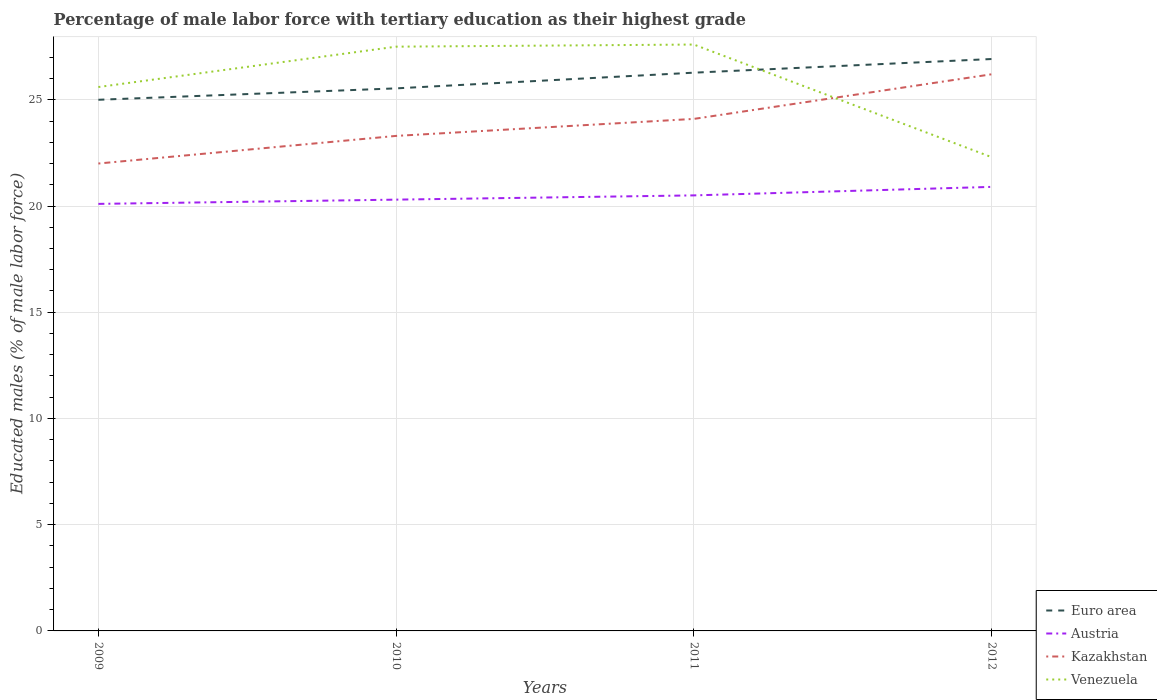How many different coloured lines are there?
Ensure brevity in your answer.  4. In which year was the percentage of male labor force with tertiary education in Euro area maximum?
Ensure brevity in your answer.  2009. What is the total percentage of male labor force with tertiary education in Venezuela in the graph?
Give a very brief answer. 5.2. What is the difference between the highest and the second highest percentage of male labor force with tertiary education in Venezuela?
Keep it short and to the point. 5.3. What is the difference between the highest and the lowest percentage of male labor force with tertiary education in Venezuela?
Provide a succinct answer. 2. Is the percentage of male labor force with tertiary education in Kazakhstan strictly greater than the percentage of male labor force with tertiary education in Venezuela over the years?
Provide a succinct answer. No. What is the difference between two consecutive major ticks on the Y-axis?
Your answer should be compact. 5. Are the values on the major ticks of Y-axis written in scientific E-notation?
Provide a succinct answer. No. Does the graph contain any zero values?
Your answer should be compact. No. What is the title of the graph?
Keep it short and to the point. Percentage of male labor force with tertiary education as their highest grade. What is the label or title of the X-axis?
Your answer should be compact. Years. What is the label or title of the Y-axis?
Your answer should be very brief. Educated males (% of male labor force). What is the Educated males (% of male labor force) of Euro area in 2009?
Your answer should be very brief. 25. What is the Educated males (% of male labor force) in Austria in 2009?
Your answer should be very brief. 20.1. What is the Educated males (% of male labor force) of Kazakhstan in 2009?
Your answer should be compact. 22. What is the Educated males (% of male labor force) of Venezuela in 2009?
Offer a terse response. 25.6. What is the Educated males (% of male labor force) of Euro area in 2010?
Make the answer very short. 25.54. What is the Educated males (% of male labor force) in Austria in 2010?
Offer a very short reply. 20.3. What is the Educated males (% of male labor force) in Kazakhstan in 2010?
Provide a succinct answer. 23.3. What is the Educated males (% of male labor force) of Euro area in 2011?
Your answer should be compact. 26.28. What is the Educated males (% of male labor force) of Kazakhstan in 2011?
Make the answer very short. 24.1. What is the Educated males (% of male labor force) in Venezuela in 2011?
Your answer should be very brief. 27.6. What is the Educated males (% of male labor force) in Euro area in 2012?
Make the answer very short. 26.92. What is the Educated males (% of male labor force) of Austria in 2012?
Provide a short and direct response. 20.9. What is the Educated males (% of male labor force) of Kazakhstan in 2012?
Give a very brief answer. 26.2. What is the Educated males (% of male labor force) in Venezuela in 2012?
Your response must be concise. 22.3. Across all years, what is the maximum Educated males (% of male labor force) of Euro area?
Keep it short and to the point. 26.92. Across all years, what is the maximum Educated males (% of male labor force) of Austria?
Keep it short and to the point. 20.9. Across all years, what is the maximum Educated males (% of male labor force) of Kazakhstan?
Give a very brief answer. 26.2. Across all years, what is the maximum Educated males (% of male labor force) of Venezuela?
Ensure brevity in your answer.  27.6. Across all years, what is the minimum Educated males (% of male labor force) of Euro area?
Ensure brevity in your answer.  25. Across all years, what is the minimum Educated males (% of male labor force) in Austria?
Give a very brief answer. 20.1. Across all years, what is the minimum Educated males (% of male labor force) in Venezuela?
Offer a terse response. 22.3. What is the total Educated males (% of male labor force) in Euro area in the graph?
Provide a short and direct response. 103.73. What is the total Educated males (% of male labor force) in Austria in the graph?
Your response must be concise. 81.8. What is the total Educated males (% of male labor force) in Kazakhstan in the graph?
Your response must be concise. 95.6. What is the total Educated males (% of male labor force) in Venezuela in the graph?
Offer a very short reply. 103. What is the difference between the Educated males (% of male labor force) of Euro area in 2009 and that in 2010?
Your answer should be compact. -0.54. What is the difference between the Educated males (% of male labor force) in Austria in 2009 and that in 2010?
Provide a short and direct response. -0.2. What is the difference between the Educated males (% of male labor force) in Euro area in 2009 and that in 2011?
Offer a terse response. -1.28. What is the difference between the Educated males (% of male labor force) in Austria in 2009 and that in 2011?
Make the answer very short. -0.4. What is the difference between the Educated males (% of male labor force) of Venezuela in 2009 and that in 2011?
Offer a very short reply. -2. What is the difference between the Educated males (% of male labor force) of Euro area in 2009 and that in 2012?
Keep it short and to the point. -1.92. What is the difference between the Educated males (% of male labor force) in Austria in 2009 and that in 2012?
Offer a terse response. -0.8. What is the difference between the Educated males (% of male labor force) in Kazakhstan in 2009 and that in 2012?
Keep it short and to the point. -4.2. What is the difference between the Educated males (% of male labor force) of Euro area in 2010 and that in 2011?
Offer a very short reply. -0.74. What is the difference between the Educated males (% of male labor force) of Austria in 2010 and that in 2011?
Provide a succinct answer. -0.2. What is the difference between the Educated males (% of male labor force) in Kazakhstan in 2010 and that in 2011?
Offer a terse response. -0.8. What is the difference between the Educated males (% of male labor force) of Venezuela in 2010 and that in 2011?
Provide a short and direct response. -0.1. What is the difference between the Educated males (% of male labor force) in Euro area in 2010 and that in 2012?
Keep it short and to the point. -1.38. What is the difference between the Educated males (% of male labor force) in Austria in 2010 and that in 2012?
Offer a terse response. -0.6. What is the difference between the Educated males (% of male labor force) in Euro area in 2011 and that in 2012?
Offer a terse response. -0.64. What is the difference between the Educated males (% of male labor force) of Kazakhstan in 2011 and that in 2012?
Your answer should be compact. -2.1. What is the difference between the Educated males (% of male labor force) in Venezuela in 2011 and that in 2012?
Give a very brief answer. 5.3. What is the difference between the Educated males (% of male labor force) in Euro area in 2009 and the Educated males (% of male labor force) in Austria in 2010?
Ensure brevity in your answer.  4.7. What is the difference between the Educated males (% of male labor force) of Euro area in 2009 and the Educated males (% of male labor force) of Kazakhstan in 2010?
Keep it short and to the point. 1.7. What is the difference between the Educated males (% of male labor force) of Euro area in 2009 and the Educated males (% of male labor force) of Venezuela in 2010?
Your answer should be compact. -2.5. What is the difference between the Educated males (% of male labor force) in Austria in 2009 and the Educated males (% of male labor force) in Kazakhstan in 2010?
Ensure brevity in your answer.  -3.2. What is the difference between the Educated males (% of male labor force) in Kazakhstan in 2009 and the Educated males (% of male labor force) in Venezuela in 2010?
Provide a short and direct response. -5.5. What is the difference between the Educated males (% of male labor force) in Euro area in 2009 and the Educated males (% of male labor force) in Austria in 2011?
Offer a terse response. 4.5. What is the difference between the Educated males (% of male labor force) of Euro area in 2009 and the Educated males (% of male labor force) of Kazakhstan in 2011?
Provide a succinct answer. 0.9. What is the difference between the Educated males (% of male labor force) of Euro area in 2009 and the Educated males (% of male labor force) of Venezuela in 2011?
Give a very brief answer. -2.6. What is the difference between the Educated males (% of male labor force) of Austria in 2009 and the Educated males (% of male labor force) of Kazakhstan in 2011?
Ensure brevity in your answer.  -4. What is the difference between the Educated males (% of male labor force) of Austria in 2009 and the Educated males (% of male labor force) of Venezuela in 2011?
Your answer should be very brief. -7.5. What is the difference between the Educated males (% of male labor force) in Euro area in 2009 and the Educated males (% of male labor force) in Austria in 2012?
Make the answer very short. 4.1. What is the difference between the Educated males (% of male labor force) in Euro area in 2009 and the Educated males (% of male labor force) in Kazakhstan in 2012?
Make the answer very short. -1.2. What is the difference between the Educated males (% of male labor force) of Euro area in 2009 and the Educated males (% of male labor force) of Venezuela in 2012?
Your answer should be compact. 2.7. What is the difference between the Educated males (% of male labor force) of Austria in 2009 and the Educated males (% of male labor force) of Venezuela in 2012?
Provide a short and direct response. -2.2. What is the difference between the Educated males (% of male labor force) of Kazakhstan in 2009 and the Educated males (% of male labor force) of Venezuela in 2012?
Your answer should be compact. -0.3. What is the difference between the Educated males (% of male labor force) in Euro area in 2010 and the Educated males (% of male labor force) in Austria in 2011?
Provide a succinct answer. 5.04. What is the difference between the Educated males (% of male labor force) of Euro area in 2010 and the Educated males (% of male labor force) of Kazakhstan in 2011?
Offer a terse response. 1.44. What is the difference between the Educated males (% of male labor force) of Euro area in 2010 and the Educated males (% of male labor force) of Venezuela in 2011?
Offer a terse response. -2.06. What is the difference between the Educated males (% of male labor force) in Austria in 2010 and the Educated males (% of male labor force) in Kazakhstan in 2011?
Your answer should be very brief. -3.8. What is the difference between the Educated males (% of male labor force) of Austria in 2010 and the Educated males (% of male labor force) of Venezuela in 2011?
Ensure brevity in your answer.  -7.3. What is the difference between the Educated males (% of male labor force) of Euro area in 2010 and the Educated males (% of male labor force) of Austria in 2012?
Ensure brevity in your answer.  4.64. What is the difference between the Educated males (% of male labor force) of Euro area in 2010 and the Educated males (% of male labor force) of Kazakhstan in 2012?
Keep it short and to the point. -0.66. What is the difference between the Educated males (% of male labor force) of Euro area in 2010 and the Educated males (% of male labor force) of Venezuela in 2012?
Your answer should be compact. 3.24. What is the difference between the Educated males (% of male labor force) of Austria in 2010 and the Educated males (% of male labor force) of Kazakhstan in 2012?
Your answer should be very brief. -5.9. What is the difference between the Educated males (% of male labor force) in Kazakhstan in 2010 and the Educated males (% of male labor force) in Venezuela in 2012?
Your answer should be very brief. 1. What is the difference between the Educated males (% of male labor force) in Euro area in 2011 and the Educated males (% of male labor force) in Austria in 2012?
Your answer should be compact. 5.38. What is the difference between the Educated males (% of male labor force) of Euro area in 2011 and the Educated males (% of male labor force) of Kazakhstan in 2012?
Provide a short and direct response. 0.08. What is the difference between the Educated males (% of male labor force) of Euro area in 2011 and the Educated males (% of male labor force) of Venezuela in 2012?
Keep it short and to the point. 3.98. What is the difference between the Educated males (% of male labor force) in Austria in 2011 and the Educated males (% of male labor force) in Kazakhstan in 2012?
Your answer should be compact. -5.7. What is the difference between the Educated males (% of male labor force) of Austria in 2011 and the Educated males (% of male labor force) of Venezuela in 2012?
Your answer should be very brief. -1.8. What is the average Educated males (% of male labor force) in Euro area per year?
Give a very brief answer. 25.93. What is the average Educated males (% of male labor force) of Austria per year?
Provide a succinct answer. 20.45. What is the average Educated males (% of male labor force) of Kazakhstan per year?
Give a very brief answer. 23.9. What is the average Educated males (% of male labor force) of Venezuela per year?
Give a very brief answer. 25.75. In the year 2009, what is the difference between the Educated males (% of male labor force) of Euro area and Educated males (% of male labor force) of Austria?
Provide a short and direct response. 4.9. In the year 2009, what is the difference between the Educated males (% of male labor force) of Euro area and Educated males (% of male labor force) of Kazakhstan?
Your answer should be compact. 3. In the year 2009, what is the difference between the Educated males (% of male labor force) of Euro area and Educated males (% of male labor force) of Venezuela?
Give a very brief answer. -0.6. In the year 2009, what is the difference between the Educated males (% of male labor force) in Kazakhstan and Educated males (% of male labor force) in Venezuela?
Keep it short and to the point. -3.6. In the year 2010, what is the difference between the Educated males (% of male labor force) of Euro area and Educated males (% of male labor force) of Austria?
Give a very brief answer. 5.24. In the year 2010, what is the difference between the Educated males (% of male labor force) of Euro area and Educated males (% of male labor force) of Kazakhstan?
Keep it short and to the point. 2.24. In the year 2010, what is the difference between the Educated males (% of male labor force) in Euro area and Educated males (% of male labor force) in Venezuela?
Provide a succinct answer. -1.96. In the year 2010, what is the difference between the Educated males (% of male labor force) in Austria and Educated males (% of male labor force) in Kazakhstan?
Your answer should be compact. -3. In the year 2010, what is the difference between the Educated males (% of male labor force) of Kazakhstan and Educated males (% of male labor force) of Venezuela?
Give a very brief answer. -4.2. In the year 2011, what is the difference between the Educated males (% of male labor force) in Euro area and Educated males (% of male labor force) in Austria?
Provide a short and direct response. 5.78. In the year 2011, what is the difference between the Educated males (% of male labor force) in Euro area and Educated males (% of male labor force) in Kazakhstan?
Your response must be concise. 2.18. In the year 2011, what is the difference between the Educated males (% of male labor force) of Euro area and Educated males (% of male labor force) of Venezuela?
Your response must be concise. -1.32. In the year 2011, what is the difference between the Educated males (% of male labor force) in Austria and Educated males (% of male labor force) in Kazakhstan?
Give a very brief answer. -3.6. In the year 2011, what is the difference between the Educated males (% of male labor force) in Kazakhstan and Educated males (% of male labor force) in Venezuela?
Your answer should be very brief. -3.5. In the year 2012, what is the difference between the Educated males (% of male labor force) of Euro area and Educated males (% of male labor force) of Austria?
Your response must be concise. 6.02. In the year 2012, what is the difference between the Educated males (% of male labor force) of Euro area and Educated males (% of male labor force) of Kazakhstan?
Offer a very short reply. 0.72. In the year 2012, what is the difference between the Educated males (% of male labor force) in Euro area and Educated males (% of male labor force) in Venezuela?
Provide a short and direct response. 4.62. In the year 2012, what is the difference between the Educated males (% of male labor force) in Austria and Educated males (% of male labor force) in Kazakhstan?
Your answer should be compact. -5.3. In the year 2012, what is the difference between the Educated males (% of male labor force) of Austria and Educated males (% of male labor force) of Venezuela?
Your answer should be very brief. -1.4. What is the ratio of the Educated males (% of male labor force) of Austria in 2009 to that in 2010?
Provide a short and direct response. 0.99. What is the ratio of the Educated males (% of male labor force) of Kazakhstan in 2009 to that in 2010?
Offer a terse response. 0.94. What is the ratio of the Educated males (% of male labor force) of Venezuela in 2009 to that in 2010?
Keep it short and to the point. 0.93. What is the ratio of the Educated males (% of male labor force) of Euro area in 2009 to that in 2011?
Make the answer very short. 0.95. What is the ratio of the Educated males (% of male labor force) in Austria in 2009 to that in 2011?
Provide a short and direct response. 0.98. What is the ratio of the Educated males (% of male labor force) of Kazakhstan in 2009 to that in 2011?
Offer a very short reply. 0.91. What is the ratio of the Educated males (% of male labor force) of Venezuela in 2009 to that in 2011?
Give a very brief answer. 0.93. What is the ratio of the Educated males (% of male labor force) of Euro area in 2009 to that in 2012?
Provide a short and direct response. 0.93. What is the ratio of the Educated males (% of male labor force) in Austria in 2009 to that in 2012?
Make the answer very short. 0.96. What is the ratio of the Educated males (% of male labor force) of Kazakhstan in 2009 to that in 2012?
Provide a short and direct response. 0.84. What is the ratio of the Educated males (% of male labor force) of Venezuela in 2009 to that in 2012?
Your answer should be very brief. 1.15. What is the ratio of the Educated males (% of male labor force) of Euro area in 2010 to that in 2011?
Make the answer very short. 0.97. What is the ratio of the Educated males (% of male labor force) in Austria in 2010 to that in 2011?
Offer a very short reply. 0.99. What is the ratio of the Educated males (% of male labor force) in Kazakhstan in 2010 to that in 2011?
Offer a terse response. 0.97. What is the ratio of the Educated males (% of male labor force) of Venezuela in 2010 to that in 2011?
Your response must be concise. 1. What is the ratio of the Educated males (% of male labor force) in Euro area in 2010 to that in 2012?
Offer a terse response. 0.95. What is the ratio of the Educated males (% of male labor force) of Austria in 2010 to that in 2012?
Your answer should be compact. 0.97. What is the ratio of the Educated males (% of male labor force) in Kazakhstan in 2010 to that in 2012?
Make the answer very short. 0.89. What is the ratio of the Educated males (% of male labor force) of Venezuela in 2010 to that in 2012?
Make the answer very short. 1.23. What is the ratio of the Educated males (% of male labor force) of Euro area in 2011 to that in 2012?
Provide a succinct answer. 0.98. What is the ratio of the Educated males (% of male labor force) of Austria in 2011 to that in 2012?
Your answer should be very brief. 0.98. What is the ratio of the Educated males (% of male labor force) of Kazakhstan in 2011 to that in 2012?
Offer a very short reply. 0.92. What is the ratio of the Educated males (% of male labor force) in Venezuela in 2011 to that in 2012?
Give a very brief answer. 1.24. What is the difference between the highest and the second highest Educated males (% of male labor force) of Euro area?
Offer a terse response. 0.64. What is the difference between the highest and the second highest Educated males (% of male labor force) in Kazakhstan?
Make the answer very short. 2.1. What is the difference between the highest and the lowest Educated males (% of male labor force) of Euro area?
Offer a terse response. 1.92. What is the difference between the highest and the lowest Educated males (% of male labor force) in Austria?
Make the answer very short. 0.8. What is the difference between the highest and the lowest Educated males (% of male labor force) in Kazakhstan?
Your answer should be very brief. 4.2. 